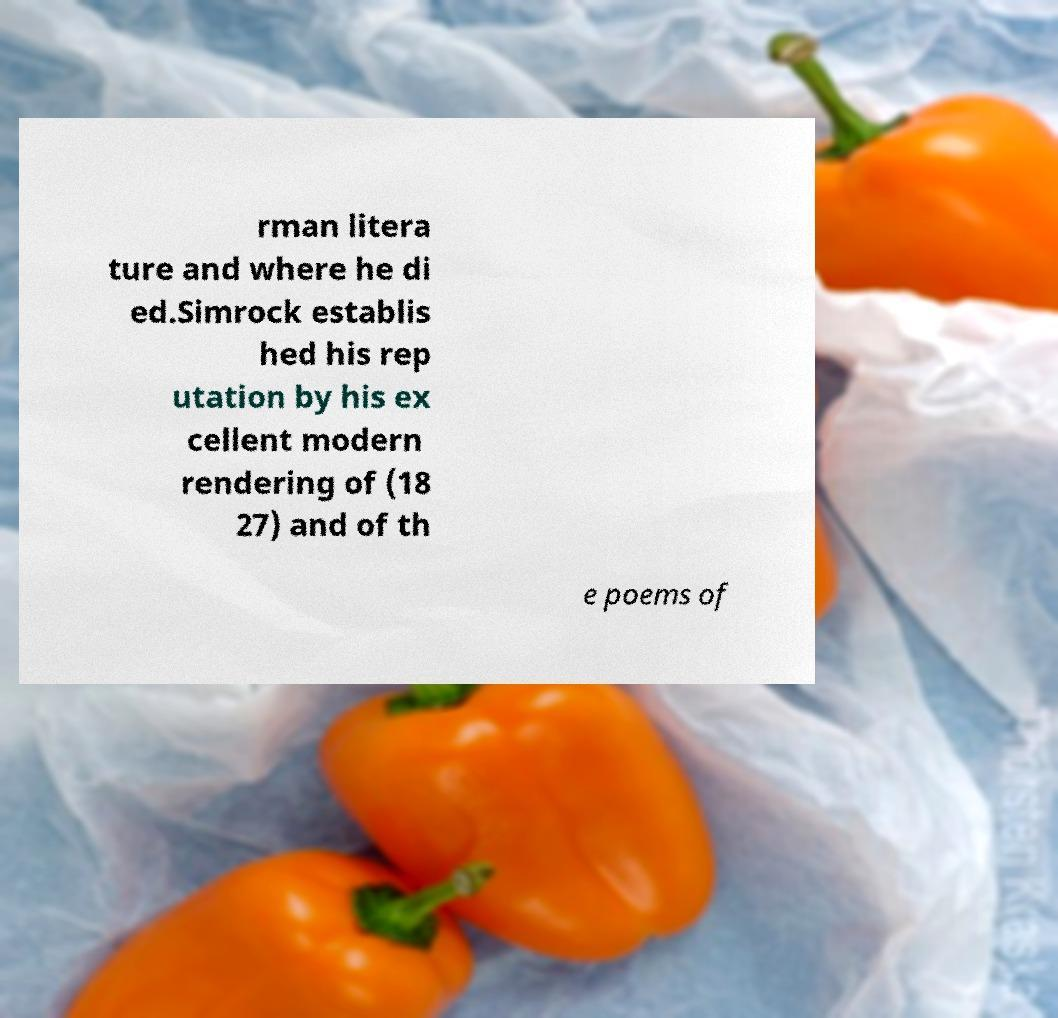Can you accurately transcribe the text from the provided image for me? rman litera ture and where he di ed.Simrock establis hed his rep utation by his ex cellent modern rendering of (18 27) and of th e poems of 